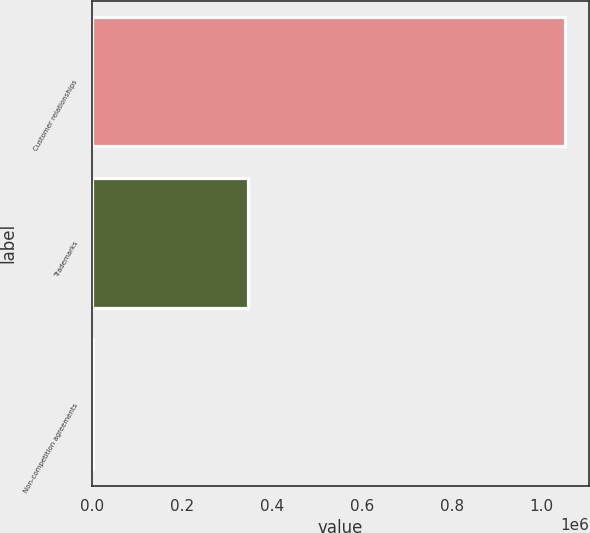<chart> <loc_0><loc_0><loc_500><loc_500><bar_chart><fcel>Customer relationships<fcel>Trademarks<fcel>Non-competition agreements<nl><fcel>1.05204e+06<fcel>346456<fcel>1894<nl></chart> 